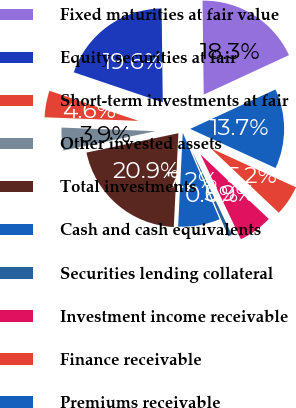Convert chart to OTSL. <chart><loc_0><loc_0><loc_500><loc_500><pie_chart><fcel>Fixed maturities at fair value<fcel>Equity securities at fair<fcel>Short-term investments at fair<fcel>Other invested assets<fcel>Total investments<fcel>Cash and cash equivalents<fcel>Securities lending collateral<fcel>Investment income receivable<fcel>Finance receivable<fcel>Premiums receivable<nl><fcel>18.3%<fcel>19.61%<fcel>4.58%<fcel>3.92%<fcel>20.91%<fcel>7.19%<fcel>0.65%<fcel>5.88%<fcel>5.23%<fcel>13.73%<nl></chart> 